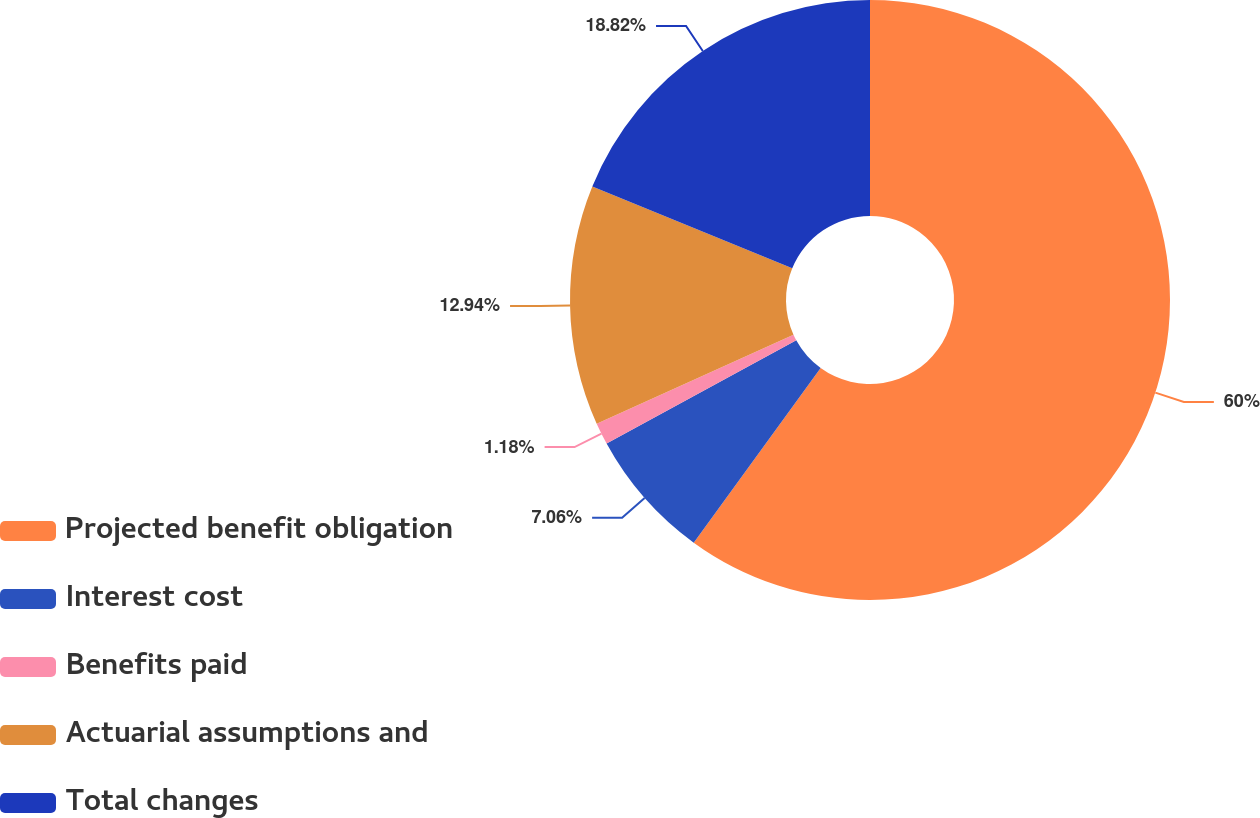Convert chart to OTSL. <chart><loc_0><loc_0><loc_500><loc_500><pie_chart><fcel>Projected benefit obligation<fcel>Interest cost<fcel>Benefits paid<fcel>Actuarial assumptions and<fcel>Total changes<nl><fcel>59.99%<fcel>7.06%<fcel>1.18%<fcel>12.94%<fcel>18.82%<nl></chart> 